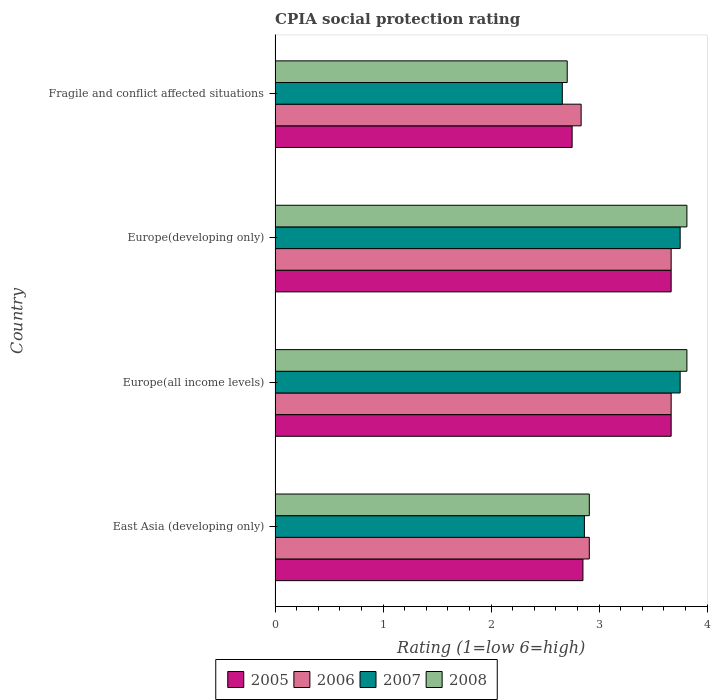How many groups of bars are there?
Your answer should be compact. 4. How many bars are there on the 4th tick from the bottom?
Provide a succinct answer. 4. What is the label of the 1st group of bars from the top?
Offer a very short reply. Fragile and conflict affected situations. What is the CPIA rating in 2007 in East Asia (developing only)?
Your answer should be compact. 2.86. Across all countries, what is the maximum CPIA rating in 2006?
Offer a terse response. 3.67. Across all countries, what is the minimum CPIA rating in 2005?
Provide a short and direct response. 2.75. In which country was the CPIA rating in 2008 maximum?
Your answer should be very brief. Europe(all income levels). In which country was the CPIA rating in 2006 minimum?
Your answer should be compact. Fragile and conflict affected situations. What is the total CPIA rating in 2005 in the graph?
Ensure brevity in your answer.  12.93. What is the difference between the CPIA rating in 2007 in Europe(developing only) and that in Fragile and conflict affected situations?
Ensure brevity in your answer.  1.09. What is the difference between the CPIA rating in 2007 in Fragile and conflict affected situations and the CPIA rating in 2008 in Europe(all income levels)?
Offer a very short reply. -1.15. What is the average CPIA rating in 2005 per country?
Your response must be concise. 3.23. What is the difference between the CPIA rating in 2007 and CPIA rating in 2005 in Fragile and conflict affected situations?
Offer a very short reply. -0.09. In how many countries, is the CPIA rating in 2007 greater than 0.8 ?
Make the answer very short. 4. What is the ratio of the CPIA rating in 2008 in Europe(developing only) to that in Fragile and conflict affected situations?
Make the answer very short. 1.41. What is the difference between the highest and the lowest CPIA rating in 2007?
Your answer should be very brief. 1.09. Is it the case that in every country, the sum of the CPIA rating in 2006 and CPIA rating in 2007 is greater than the sum of CPIA rating in 2008 and CPIA rating in 2005?
Provide a short and direct response. No. What does the 3rd bar from the top in Europe(all income levels) represents?
Offer a terse response. 2006. What does the 4th bar from the bottom in Europe(developing only) represents?
Your answer should be compact. 2008. How many countries are there in the graph?
Offer a very short reply. 4. What is the difference between two consecutive major ticks on the X-axis?
Provide a succinct answer. 1. Does the graph contain any zero values?
Ensure brevity in your answer.  No. Does the graph contain grids?
Offer a very short reply. No. How many legend labels are there?
Your response must be concise. 4. What is the title of the graph?
Offer a terse response. CPIA social protection rating. Does "1971" appear as one of the legend labels in the graph?
Provide a succinct answer. No. What is the label or title of the Y-axis?
Offer a terse response. Country. What is the Rating (1=low 6=high) of 2005 in East Asia (developing only)?
Your answer should be compact. 2.85. What is the Rating (1=low 6=high) of 2006 in East Asia (developing only)?
Your response must be concise. 2.91. What is the Rating (1=low 6=high) in 2007 in East Asia (developing only)?
Offer a terse response. 2.86. What is the Rating (1=low 6=high) in 2008 in East Asia (developing only)?
Offer a very short reply. 2.91. What is the Rating (1=low 6=high) in 2005 in Europe(all income levels)?
Your answer should be compact. 3.67. What is the Rating (1=low 6=high) in 2006 in Europe(all income levels)?
Your response must be concise. 3.67. What is the Rating (1=low 6=high) in 2007 in Europe(all income levels)?
Provide a succinct answer. 3.75. What is the Rating (1=low 6=high) of 2008 in Europe(all income levels)?
Your answer should be very brief. 3.81. What is the Rating (1=low 6=high) in 2005 in Europe(developing only)?
Keep it short and to the point. 3.67. What is the Rating (1=low 6=high) of 2006 in Europe(developing only)?
Give a very brief answer. 3.67. What is the Rating (1=low 6=high) of 2007 in Europe(developing only)?
Provide a short and direct response. 3.75. What is the Rating (1=low 6=high) in 2008 in Europe(developing only)?
Give a very brief answer. 3.81. What is the Rating (1=low 6=high) of 2005 in Fragile and conflict affected situations?
Make the answer very short. 2.75. What is the Rating (1=low 6=high) of 2006 in Fragile and conflict affected situations?
Give a very brief answer. 2.83. What is the Rating (1=low 6=high) in 2007 in Fragile and conflict affected situations?
Give a very brief answer. 2.66. What is the Rating (1=low 6=high) in 2008 in Fragile and conflict affected situations?
Make the answer very short. 2.7. Across all countries, what is the maximum Rating (1=low 6=high) in 2005?
Ensure brevity in your answer.  3.67. Across all countries, what is the maximum Rating (1=low 6=high) in 2006?
Your response must be concise. 3.67. Across all countries, what is the maximum Rating (1=low 6=high) in 2007?
Keep it short and to the point. 3.75. Across all countries, what is the maximum Rating (1=low 6=high) of 2008?
Keep it short and to the point. 3.81. Across all countries, what is the minimum Rating (1=low 6=high) of 2005?
Make the answer very short. 2.75. Across all countries, what is the minimum Rating (1=low 6=high) in 2006?
Your response must be concise. 2.83. Across all countries, what is the minimum Rating (1=low 6=high) in 2007?
Ensure brevity in your answer.  2.66. Across all countries, what is the minimum Rating (1=low 6=high) of 2008?
Provide a succinct answer. 2.7. What is the total Rating (1=low 6=high) in 2005 in the graph?
Provide a short and direct response. 12.93. What is the total Rating (1=low 6=high) of 2006 in the graph?
Your answer should be very brief. 13.08. What is the total Rating (1=low 6=high) of 2007 in the graph?
Offer a terse response. 13.02. What is the total Rating (1=low 6=high) of 2008 in the graph?
Give a very brief answer. 13.24. What is the difference between the Rating (1=low 6=high) of 2005 in East Asia (developing only) and that in Europe(all income levels)?
Your response must be concise. -0.82. What is the difference between the Rating (1=low 6=high) of 2006 in East Asia (developing only) and that in Europe(all income levels)?
Offer a terse response. -0.76. What is the difference between the Rating (1=low 6=high) in 2007 in East Asia (developing only) and that in Europe(all income levels)?
Make the answer very short. -0.89. What is the difference between the Rating (1=low 6=high) of 2008 in East Asia (developing only) and that in Europe(all income levels)?
Your response must be concise. -0.9. What is the difference between the Rating (1=low 6=high) of 2005 in East Asia (developing only) and that in Europe(developing only)?
Keep it short and to the point. -0.82. What is the difference between the Rating (1=low 6=high) in 2006 in East Asia (developing only) and that in Europe(developing only)?
Keep it short and to the point. -0.76. What is the difference between the Rating (1=low 6=high) in 2007 in East Asia (developing only) and that in Europe(developing only)?
Your response must be concise. -0.89. What is the difference between the Rating (1=low 6=high) of 2008 in East Asia (developing only) and that in Europe(developing only)?
Provide a succinct answer. -0.9. What is the difference between the Rating (1=low 6=high) in 2005 in East Asia (developing only) and that in Fragile and conflict affected situations?
Make the answer very short. 0.1. What is the difference between the Rating (1=low 6=high) in 2006 in East Asia (developing only) and that in Fragile and conflict affected situations?
Your answer should be compact. 0.08. What is the difference between the Rating (1=low 6=high) in 2007 in East Asia (developing only) and that in Fragile and conflict affected situations?
Offer a terse response. 0.2. What is the difference between the Rating (1=low 6=high) of 2008 in East Asia (developing only) and that in Fragile and conflict affected situations?
Keep it short and to the point. 0.2. What is the difference between the Rating (1=low 6=high) in 2005 in Europe(all income levels) and that in Europe(developing only)?
Ensure brevity in your answer.  0. What is the difference between the Rating (1=low 6=high) in 2005 in Europe(all income levels) and that in Fragile and conflict affected situations?
Your response must be concise. 0.92. What is the difference between the Rating (1=low 6=high) of 2007 in Europe(all income levels) and that in Fragile and conflict affected situations?
Your answer should be very brief. 1.09. What is the difference between the Rating (1=low 6=high) in 2008 in Europe(all income levels) and that in Fragile and conflict affected situations?
Your answer should be very brief. 1.11. What is the difference between the Rating (1=low 6=high) in 2005 in Europe(developing only) and that in Fragile and conflict affected situations?
Offer a terse response. 0.92. What is the difference between the Rating (1=low 6=high) in 2006 in Europe(developing only) and that in Fragile and conflict affected situations?
Your answer should be compact. 0.83. What is the difference between the Rating (1=low 6=high) in 2008 in Europe(developing only) and that in Fragile and conflict affected situations?
Offer a terse response. 1.11. What is the difference between the Rating (1=low 6=high) of 2005 in East Asia (developing only) and the Rating (1=low 6=high) of 2006 in Europe(all income levels)?
Your answer should be compact. -0.82. What is the difference between the Rating (1=low 6=high) of 2005 in East Asia (developing only) and the Rating (1=low 6=high) of 2008 in Europe(all income levels)?
Provide a succinct answer. -0.96. What is the difference between the Rating (1=low 6=high) of 2006 in East Asia (developing only) and the Rating (1=low 6=high) of 2007 in Europe(all income levels)?
Make the answer very short. -0.84. What is the difference between the Rating (1=low 6=high) in 2006 in East Asia (developing only) and the Rating (1=low 6=high) in 2008 in Europe(all income levels)?
Ensure brevity in your answer.  -0.9. What is the difference between the Rating (1=low 6=high) in 2007 in East Asia (developing only) and the Rating (1=low 6=high) in 2008 in Europe(all income levels)?
Your response must be concise. -0.95. What is the difference between the Rating (1=low 6=high) in 2005 in East Asia (developing only) and the Rating (1=low 6=high) in 2006 in Europe(developing only)?
Offer a terse response. -0.82. What is the difference between the Rating (1=low 6=high) of 2005 in East Asia (developing only) and the Rating (1=low 6=high) of 2007 in Europe(developing only)?
Give a very brief answer. -0.9. What is the difference between the Rating (1=low 6=high) in 2005 in East Asia (developing only) and the Rating (1=low 6=high) in 2008 in Europe(developing only)?
Keep it short and to the point. -0.96. What is the difference between the Rating (1=low 6=high) of 2006 in East Asia (developing only) and the Rating (1=low 6=high) of 2007 in Europe(developing only)?
Keep it short and to the point. -0.84. What is the difference between the Rating (1=low 6=high) in 2006 in East Asia (developing only) and the Rating (1=low 6=high) in 2008 in Europe(developing only)?
Offer a very short reply. -0.9. What is the difference between the Rating (1=low 6=high) in 2007 in East Asia (developing only) and the Rating (1=low 6=high) in 2008 in Europe(developing only)?
Give a very brief answer. -0.95. What is the difference between the Rating (1=low 6=high) in 2005 in East Asia (developing only) and the Rating (1=low 6=high) in 2006 in Fragile and conflict affected situations?
Give a very brief answer. 0.02. What is the difference between the Rating (1=low 6=high) in 2005 in East Asia (developing only) and the Rating (1=low 6=high) in 2007 in Fragile and conflict affected situations?
Provide a succinct answer. 0.19. What is the difference between the Rating (1=low 6=high) in 2005 in East Asia (developing only) and the Rating (1=low 6=high) in 2008 in Fragile and conflict affected situations?
Provide a succinct answer. 0.15. What is the difference between the Rating (1=low 6=high) of 2006 in East Asia (developing only) and the Rating (1=low 6=high) of 2008 in Fragile and conflict affected situations?
Offer a terse response. 0.2. What is the difference between the Rating (1=low 6=high) of 2007 in East Asia (developing only) and the Rating (1=low 6=high) of 2008 in Fragile and conflict affected situations?
Keep it short and to the point. 0.16. What is the difference between the Rating (1=low 6=high) of 2005 in Europe(all income levels) and the Rating (1=low 6=high) of 2007 in Europe(developing only)?
Make the answer very short. -0.08. What is the difference between the Rating (1=low 6=high) in 2005 in Europe(all income levels) and the Rating (1=low 6=high) in 2008 in Europe(developing only)?
Offer a very short reply. -0.15. What is the difference between the Rating (1=low 6=high) in 2006 in Europe(all income levels) and the Rating (1=low 6=high) in 2007 in Europe(developing only)?
Your response must be concise. -0.08. What is the difference between the Rating (1=low 6=high) of 2006 in Europe(all income levels) and the Rating (1=low 6=high) of 2008 in Europe(developing only)?
Your answer should be very brief. -0.15. What is the difference between the Rating (1=low 6=high) of 2007 in Europe(all income levels) and the Rating (1=low 6=high) of 2008 in Europe(developing only)?
Offer a very short reply. -0.06. What is the difference between the Rating (1=low 6=high) of 2005 in Europe(all income levels) and the Rating (1=low 6=high) of 2006 in Fragile and conflict affected situations?
Your answer should be very brief. 0.83. What is the difference between the Rating (1=low 6=high) in 2005 in Europe(all income levels) and the Rating (1=low 6=high) in 2007 in Fragile and conflict affected situations?
Ensure brevity in your answer.  1.01. What is the difference between the Rating (1=low 6=high) in 2005 in Europe(all income levels) and the Rating (1=low 6=high) in 2008 in Fragile and conflict affected situations?
Keep it short and to the point. 0.96. What is the difference between the Rating (1=low 6=high) in 2006 in Europe(all income levels) and the Rating (1=low 6=high) in 2007 in Fragile and conflict affected situations?
Provide a short and direct response. 1.01. What is the difference between the Rating (1=low 6=high) in 2006 in Europe(all income levels) and the Rating (1=low 6=high) in 2008 in Fragile and conflict affected situations?
Offer a very short reply. 0.96. What is the difference between the Rating (1=low 6=high) of 2007 in Europe(all income levels) and the Rating (1=low 6=high) of 2008 in Fragile and conflict affected situations?
Your response must be concise. 1.05. What is the difference between the Rating (1=low 6=high) of 2005 in Europe(developing only) and the Rating (1=low 6=high) of 2006 in Fragile and conflict affected situations?
Provide a short and direct response. 0.83. What is the difference between the Rating (1=low 6=high) of 2005 in Europe(developing only) and the Rating (1=low 6=high) of 2007 in Fragile and conflict affected situations?
Your response must be concise. 1.01. What is the difference between the Rating (1=low 6=high) in 2005 in Europe(developing only) and the Rating (1=low 6=high) in 2008 in Fragile and conflict affected situations?
Keep it short and to the point. 0.96. What is the difference between the Rating (1=low 6=high) of 2006 in Europe(developing only) and the Rating (1=low 6=high) of 2007 in Fragile and conflict affected situations?
Your answer should be very brief. 1.01. What is the difference between the Rating (1=low 6=high) in 2006 in Europe(developing only) and the Rating (1=low 6=high) in 2008 in Fragile and conflict affected situations?
Keep it short and to the point. 0.96. What is the difference between the Rating (1=low 6=high) of 2007 in Europe(developing only) and the Rating (1=low 6=high) of 2008 in Fragile and conflict affected situations?
Make the answer very short. 1.05. What is the average Rating (1=low 6=high) in 2005 per country?
Ensure brevity in your answer.  3.23. What is the average Rating (1=low 6=high) of 2006 per country?
Provide a succinct answer. 3.27. What is the average Rating (1=low 6=high) of 2007 per country?
Offer a very short reply. 3.26. What is the average Rating (1=low 6=high) in 2008 per country?
Offer a very short reply. 3.31. What is the difference between the Rating (1=low 6=high) in 2005 and Rating (1=low 6=high) in 2006 in East Asia (developing only)?
Give a very brief answer. -0.06. What is the difference between the Rating (1=low 6=high) of 2005 and Rating (1=low 6=high) of 2007 in East Asia (developing only)?
Offer a terse response. -0.01. What is the difference between the Rating (1=low 6=high) in 2005 and Rating (1=low 6=high) in 2008 in East Asia (developing only)?
Offer a terse response. -0.06. What is the difference between the Rating (1=low 6=high) of 2006 and Rating (1=low 6=high) of 2007 in East Asia (developing only)?
Offer a very short reply. 0.05. What is the difference between the Rating (1=low 6=high) in 2007 and Rating (1=low 6=high) in 2008 in East Asia (developing only)?
Your answer should be very brief. -0.05. What is the difference between the Rating (1=low 6=high) of 2005 and Rating (1=low 6=high) of 2006 in Europe(all income levels)?
Keep it short and to the point. 0. What is the difference between the Rating (1=low 6=high) of 2005 and Rating (1=low 6=high) of 2007 in Europe(all income levels)?
Make the answer very short. -0.08. What is the difference between the Rating (1=low 6=high) in 2005 and Rating (1=low 6=high) in 2008 in Europe(all income levels)?
Make the answer very short. -0.15. What is the difference between the Rating (1=low 6=high) in 2006 and Rating (1=low 6=high) in 2007 in Europe(all income levels)?
Offer a very short reply. -0.08. What is the difference between the Rating (1=low 6=high) in 2006 and Rating (1=low 6=high) in 2008 in Europe(all income levels)?
Provide a succinct answer. -0.15. What is the difference between the Rating (1=low 6=high) in 2007 and Rating (1=low 6=high) in 2008 in Europe(all income levels)?
Keep it short and to the point. -0.06. What is the difference between the Rating (1=low 6=high) of 2005 and Rating (1=low 6=high) of 2006 in Europe(developing only)?
Keep it short and to the point. 0. What is the difference between the Rating (1=low 6=high) of 2005 and Rating (1=low 6=high) of 2007 in Europe(developing only)?
Offer a terse response. -0.08. What is the difference between the Rating (1=low 6=high) in 2005 and Rating (1=low 6=high) in 2008 in Europe(developing only)?
Offer a very short reply. -0.15. What is the difference between the Rating (1=low 6=high) in 2006 and Rating (1=low 6=high) in 2007 in Europe(developing only)?
Make the answer very short. -0.08. What is the difference between the Rating (1=low 6=high) in 2006 and Rating (1=low 6=high) in 2008 in Europe(developing only)?
Ensure brevity in your answer.  -0.15. What is the difference between the Rating (1=low 6=high) in 2007 and Rating (1=low 6=high) in 2008 in Europe(developing only)?
Keep it short and to the point. -0.06. What is the difference between the Rating (1=low 6=high) in 2005 and Rating (1=low 6=high) in 2006 in Fragile and conflict affected situations?
Provide a succinct answer. -0.08. What is the difference between the Rating (1=low 6=high) in 2005 and Rating (1=low 6=high) in 2007 in Fragile and conflict affected situations?
Offer a very short reply. 0.09. What is the difference between the Rating (1=low 6=high) in 2005 and Rating (1=low 6=high) in 2008 in Fragile and conflict affected situations?
Offer a terse response. 0.05. What is the difference between the Rating (1=low 6=high) in 2006 and Rating (1=low 6=high) in 2007 in Fragile and conflict affected situations?
Your response must be concise. 0.17. What is the difference between the Rating (1=low 6=high) in 2006 and Rating (1=low 6=high) in 2008 in Fragile and conflict affected situations?
Give a very brief answer. 0.13. What is the difference between the Rating (1=low 6=high) in 2007 and Rating (1=low 6=high) in 2008 in Fragile and conflict affected situations?
Provide a succinct answer. -0.05. What is the ratio of the Rating (1=low 6=high) of 2005 in East Asia (developing only) to that in Europe(all income levels)?
Your answer should be very brief. 0.78. What is the ratio of the Rating (1=low 6=high) of 2006 in East Asia (developing only) to that in Europe(all income levels)?
Your answer should be very brief. 0.79. What is the ratio of the Rating (1=low 6=high) in 2007 in East Asia (developing only) to that in Europe(all income levels)?
Your answer should be compact. 0.76. What is the ratio of the Rating (1=low 6=high) in 2008 in East Asia (developing only) to that in Europe(all income levels)?
Make the answer very short. 0.76. What is the ratio of the Rating (1=low 6=high) in 2005 in East Asia (developing only) to that in Europe(developing only)?
Offer a terse response. 0.78. What is the ratio of the Rating (1=low 6=high) of 2006 in East Asia (developing only) to that in Europe(developing only)?
Offer a very short reply. 0.79. What is the ratio of the Rating (1=low 6=high) in 2007 in East Asia (developing only) to that in Europe(developing only)?
Make the answer very short. 0.76. What is the ratio of the Rating (1=low 6=high) in 2008 in East Asia (developing only) to that in Europe(developing only)?
Your response must be concise. 0.76. What is the ratio of the Rating (1=low 6=high) of 2005 in East Asia (developing only) to that in Fragile and conflict affected situations?
Ensure brevity in your answer.  1.04. What is the ratio of the Rating (1=low 6=high) in 2006 in East Asia (developing only) to that in Fragile and conflict affected situations?
Your response must be concise. 1.03. What is the ratio of the Rating (1=low 6=high) of 2007 in East Asia (developing only) to that in Fragile and conflict affected situations?
Provide a succinct answer. 1.08. What is the ratio of the Rating (1=low 6=high) of 2008 in East Asia (developing only) to that in Fragile and conflict affected situations?
Keep it short and to the point. 1.08. What is the ratio of the Rating (1=low 6=high) in 2008 in Europe(all income levels) to that in Europe(developing only)?
Your answer should be compact. 1. What is the ratio of the Rating (1=low 6=high) in 2006 in Europe(all income levels) to that in Fragile and conflict affected situations?
Your answer should be very brief. 1.29. What is the ratio of the Rating (1=low 6=high) of 2007 in Europe(all income levels) to that in Fragile and conflict affected situations?
Provide a succinct answer. 1.41. What is the ratio of the Rating (1=low 6=high) of 2008 in Europe(all income levels) to that in Fragile and conflict affected situations?
Offer a terse response. 1.41. What is the ratio of the Rating (1=low 6=high) in 2006 in Europe(developing only) to that in Fragile and conflict affected situations?
Your response must be concise. 1.29. What is the ratio of the Rating (1=low 6=high) in 2007 in Europe(developing only) to that in Fragile and conflict affected situations?
Provide a succinct answer. 1.41. What is the ratio of the Rating (1=low 6=high) in 2008 in Europe(developing only) to that in Fragile and conflict affected situations?
Your answer should be compact. 1.41. What is the difference between the highest and the lowest Rating (1=low 6=high) in 2005?
Offer a very short reply. 0.92. What is the difference between the highest and the lowest Rating (1=low 6=high) of 2008?
Your response must be concise. 1.11. 